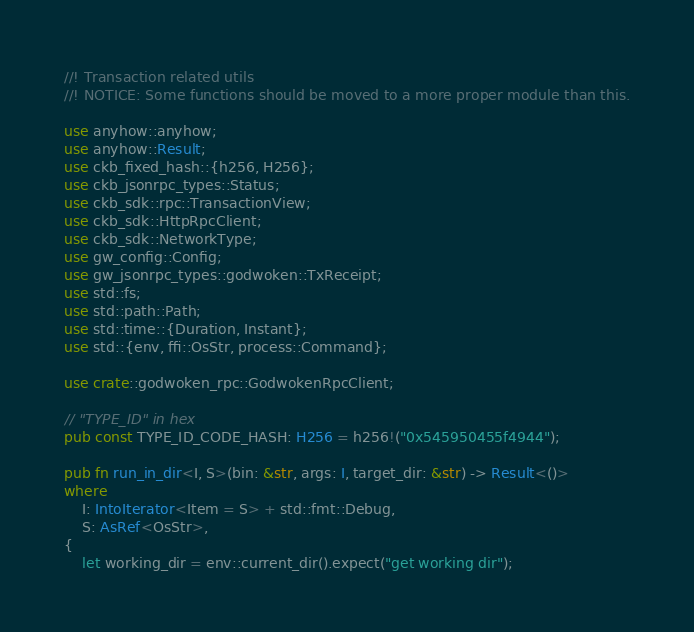<code> <loc_0><loc_0><loc_500><loc_500><_Rust_>//! Transaction related utils
//! NOTICE: Some functions should be moved to a more proper module than this.

use anyhow::anyhow;
use anyhow::Result;
use ckb_fixed_hash::{h256, H256};
use ckb_jsonrpc_types::Status;
use ckb_sdk::rpc::TransactionView;
use ckb_sdk::HttpRpcClient;
use ckb_sdk::NetworkType;
use gw_config::Config;
use gw_jsonrpc_types::godwoken::TxReceipt;
use std::fs;
use std::path::Path;
use std::time::{Duration, Instant};
use std::{env, ffi::OsStr, process::Command};

use crate::godwoken_rpc::GodwokenRpcClient;

// "TYPE_ID" in hex
pub const TYPE_ID_CODE_HASH: H256 = h256!("0x545950455f4944");

pub fn run_in_dir<I, S>(bin: &str, args: I, target_dir: &str) -> Result<()>
where
    I: IntoIterator<Item = S> + std::fmt::Debug,
    S: AsRef<OsStr>,
{
    let working_dir = env::current_dir().expect("get working dir");</code> 